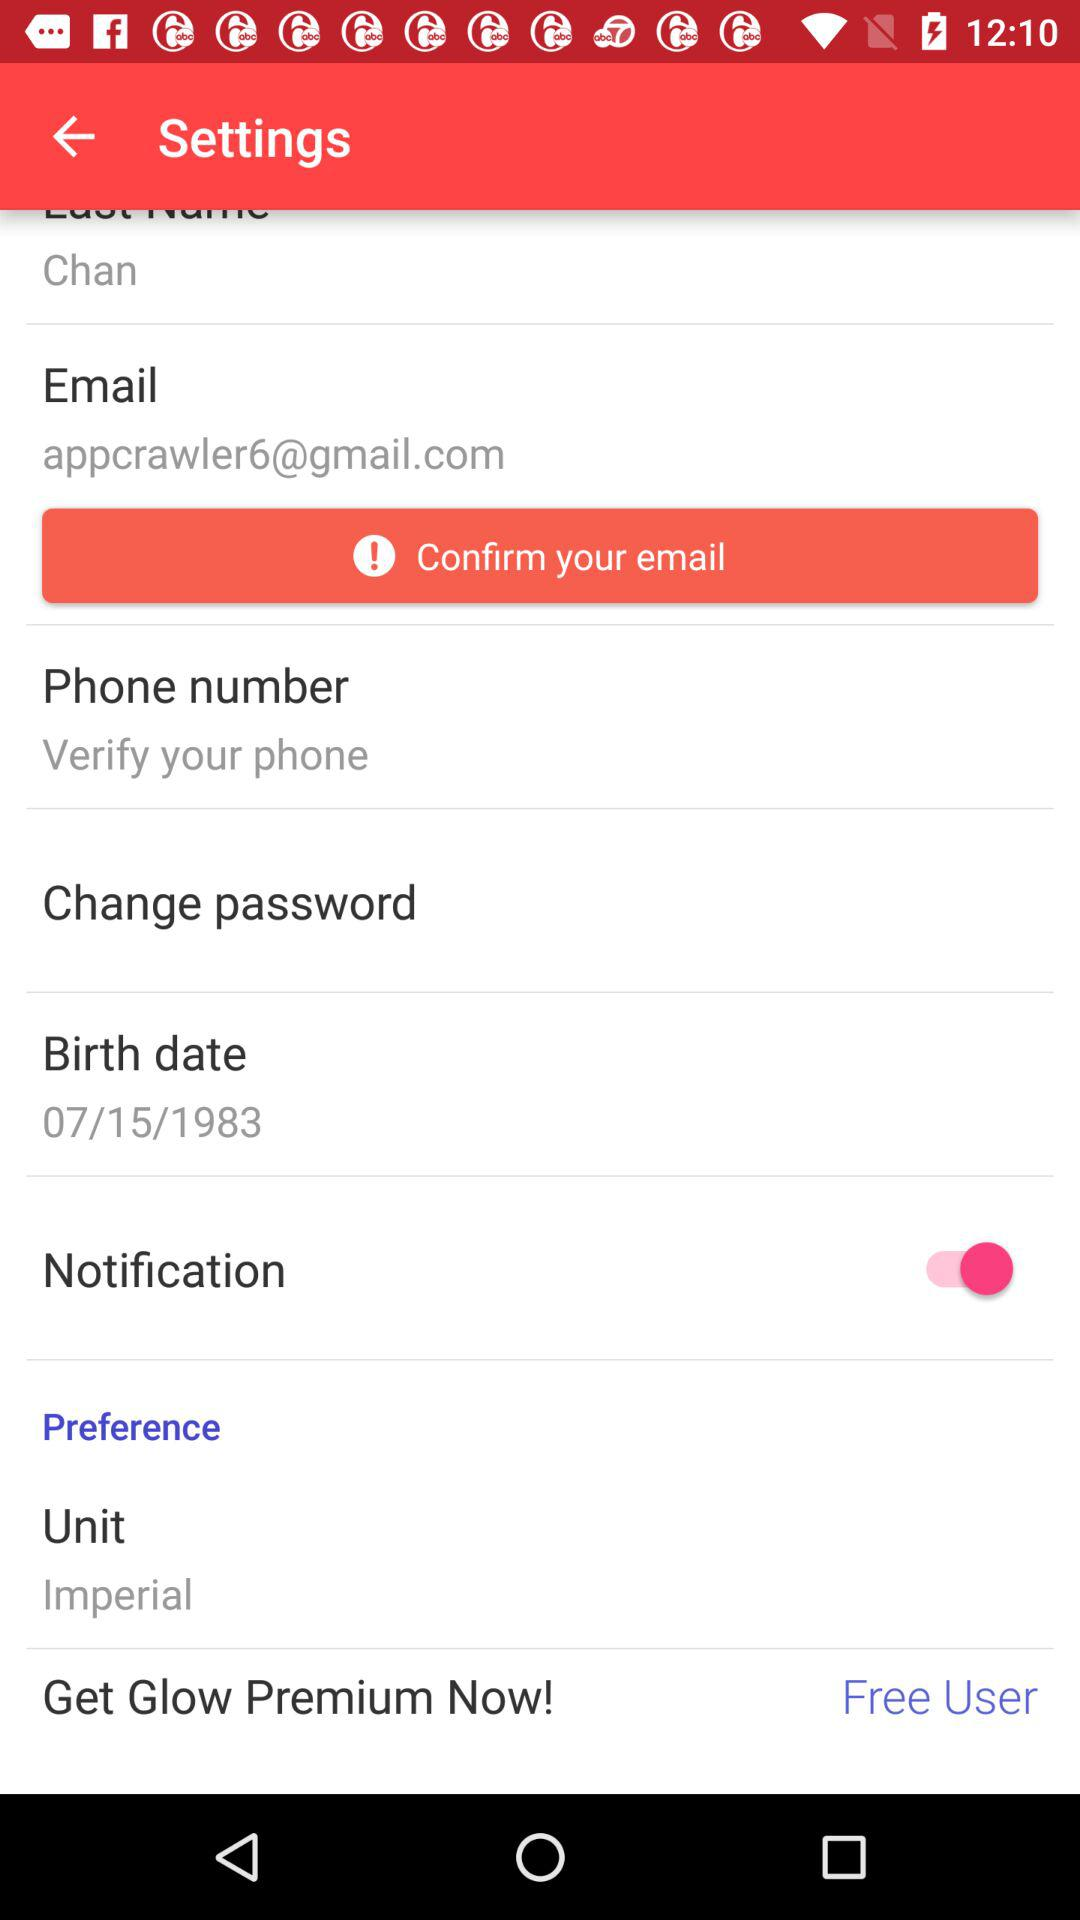What is the status of the "Notification"? The status is "on". 